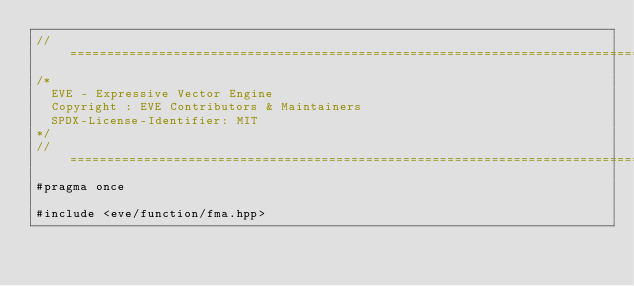Convert code to text. <code><loc_0><loc_0><loc_500><loc_500><_C++_>//==================================================================================================
/*
  EVE - Expressive Vector Engine
  Copyright : EVE Contributors & Maintainers
  SPDX-License-Identifier: MIT
*/
//==================================================================================================
#pragma once

#include <eve/function/fma.hpp></code> 